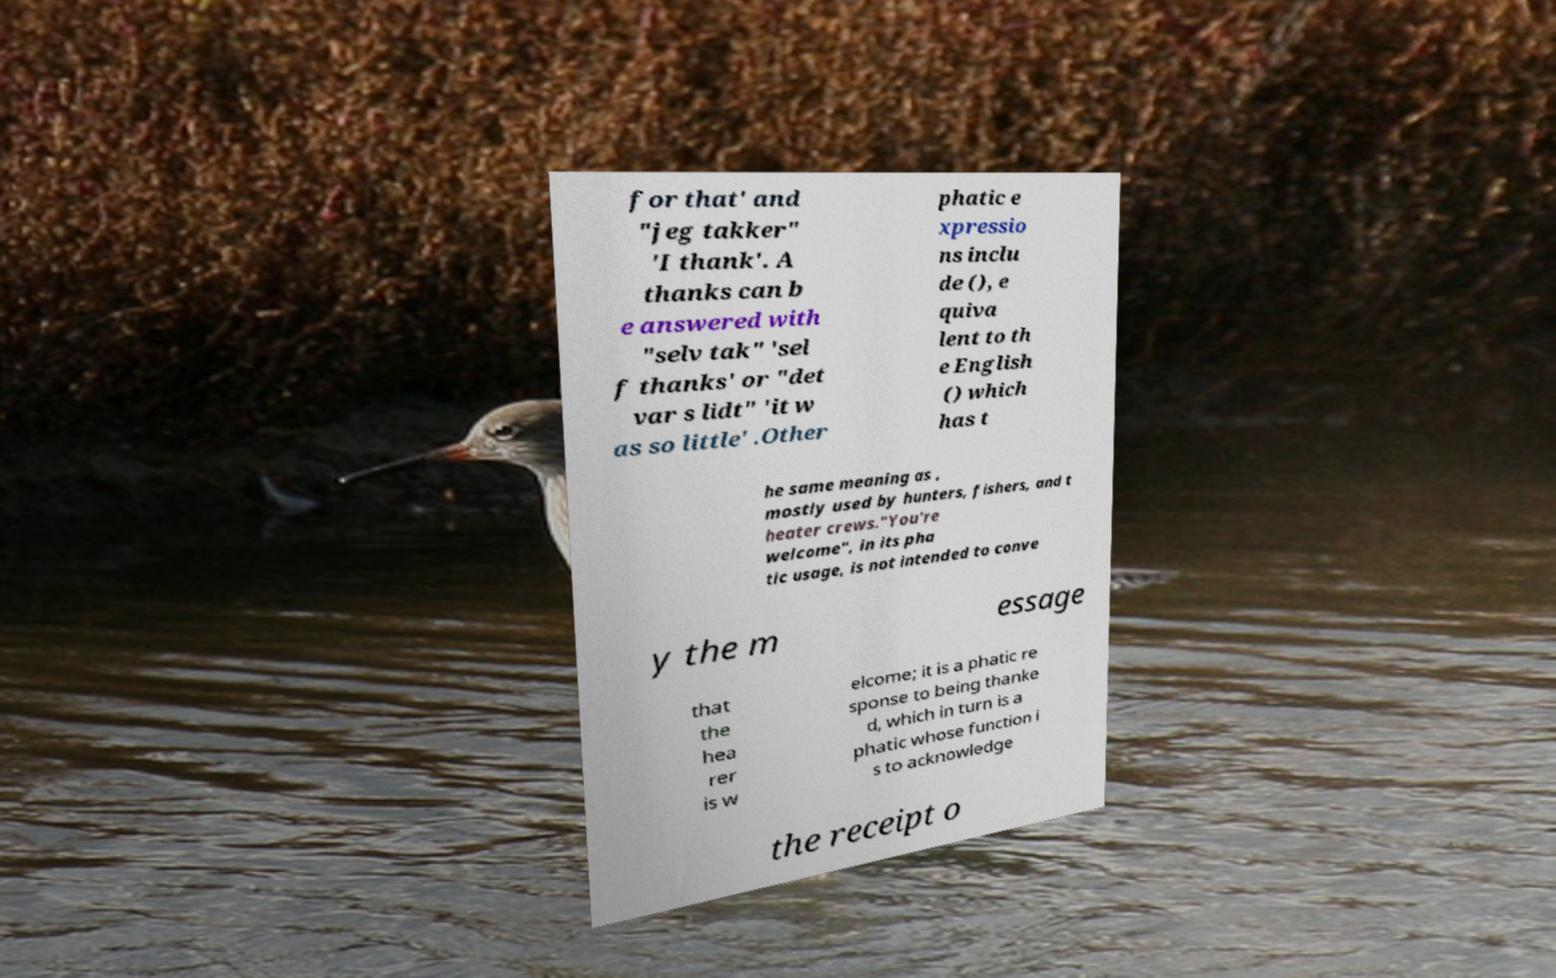Can you accurately transcribe the text from the provided image for me? for that' and "jeg takker" 'I thank'. A thanks can b e answered with "selv tak" 'sel f thanks' or "det var s lidt" 'it w as so little' .Other phatic e xpressio ns inclu de (), e quiva lent to th e English () which has t he same meaning as , mostly used by hunters, fishers, and t heater crews."You're welcome", in its pha tic usage, is not intended to conve y the m essage that the hea rer is w elcome; it is a phatic re sponse to being thanke d, which in turn is a phatic whose function i s to acknowledge the receipt o 